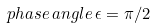<formula> <loc_0><loc_0><loc_500><loc_500>p h a s e \, a n g l e \, \epsilon = \pi / 2</formula> 